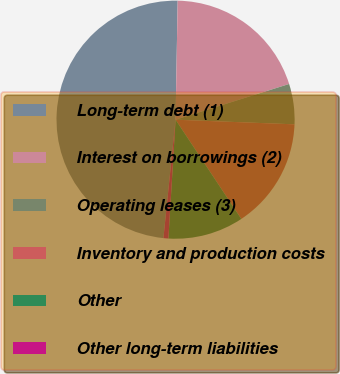Convert chart to OTSL. <chart><loc_0><loc_0><loc_500><loc_500><pie_chart><fcel>Long-term debt (1)<fcel>Interest on borrowings (2)<fcel>Operating leases (3)<fcel>Inventory and production costs<fcel>Other<fcel>Other long-term liabilities<nl><fcel>48.66%<fcel>19.87%<fcel>5.47%<fcel>15.07%<fcel>10.27%<fcel>0.67%<nl></chart> 